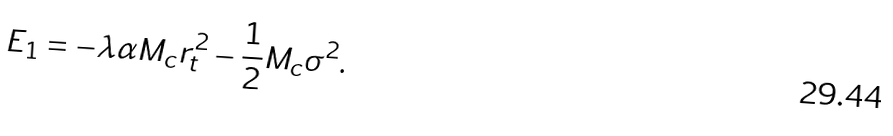<formula> <loc_0><loc_0><loc_500><loc_500>E _ { 1 } = - \lambda \alpha M _ { c } r _ { t } ^ { 2 } - \frac { 1 } { 2 } M _ { c } \sigma ^ { 2 } .</formula> 